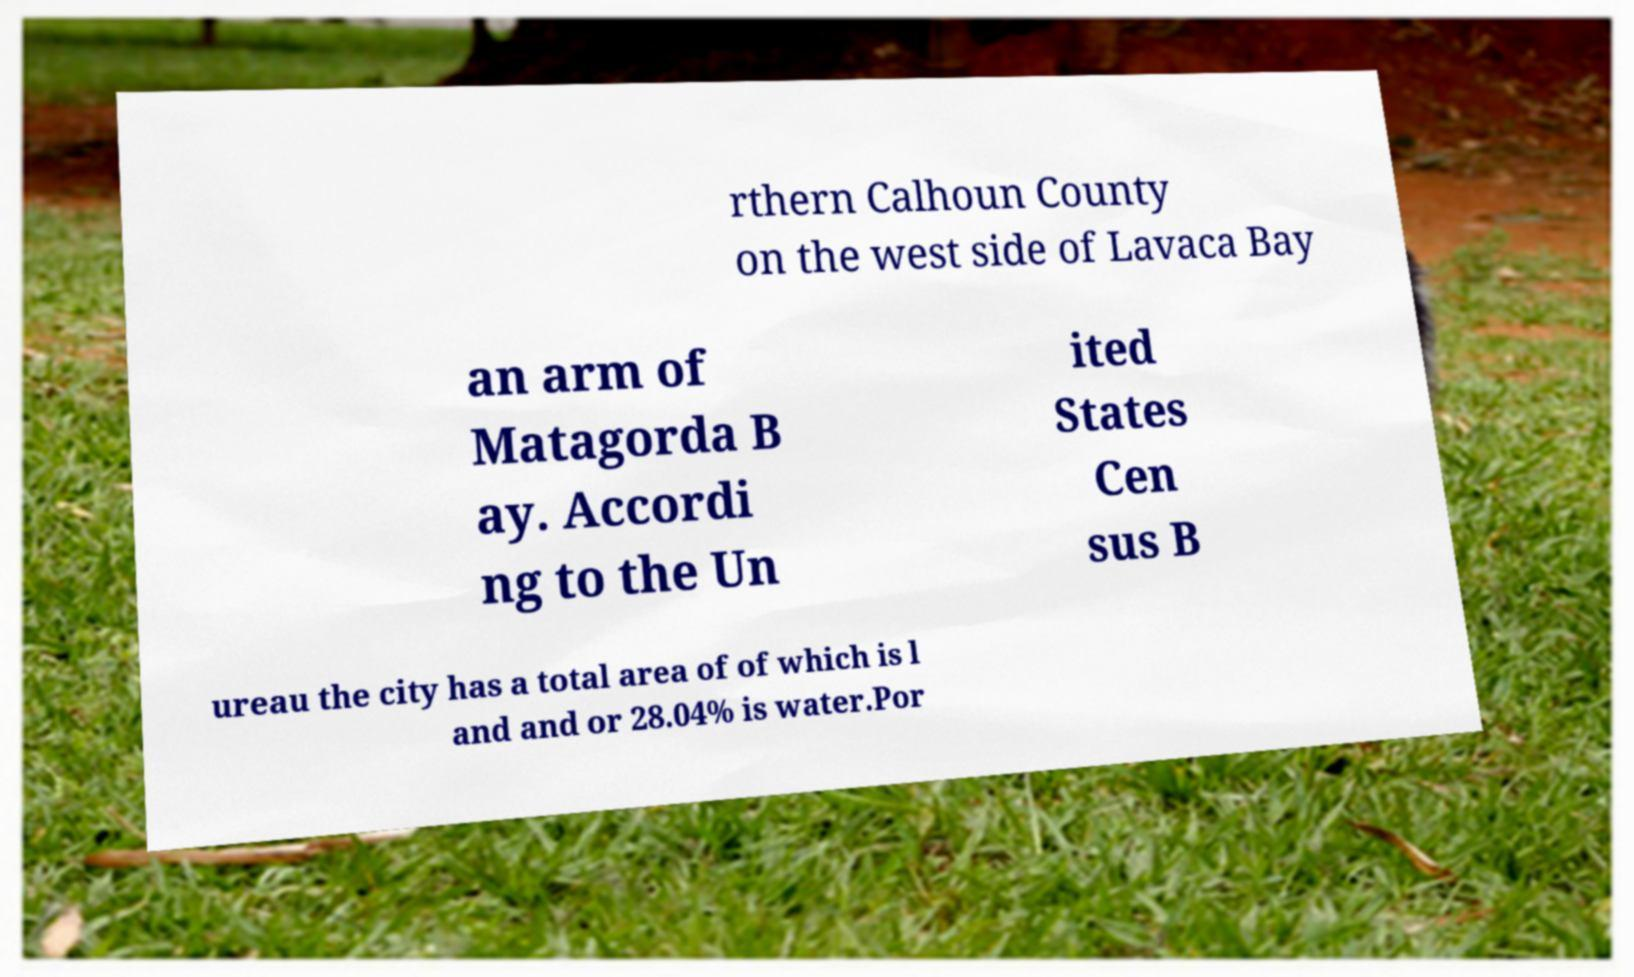What messages or text are displayed in this image? I need them in a readable, typed format. rthern Calhoun County on the west side of Lavaca Bay an arm of Matagorda B ay. Accordi ng to the Un ited States Cen sus B ureau the city has a total area of of which is l and and or 28.04% is water.Por 